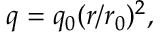<formula> <loc_0><loc_0><loc_500><loc_500>q = q _ { 0 } ( r / r _ { 0 } ) ^ { 2 } ,</formula> 